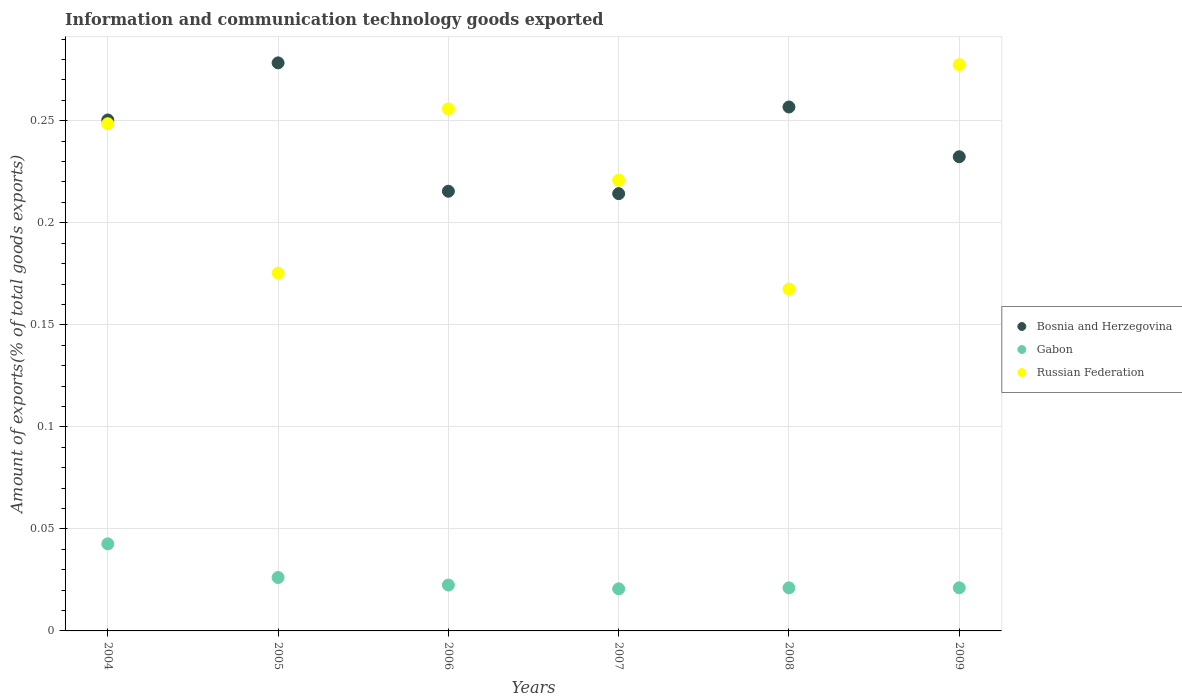Is the number of dotlines equal to the number of legend labels?
Make the answer very short. Yes. What is the amount of goods exported in Gabon in 2009?
Offer a terse response. 0.02. Across all years, what is the maximum amount of goods exported in Gabon?
Your response must be concise. 0.04. Across all years, what is the minimum amount of goods exported in Gabon?
Provide a succinct answer. 0.02. What is the total amount of goods exported in Bosnia and Herzegovina in the graph?
Your response must be concise. 1.45. What is the difference between the amount of goods exported in Gabon in 2004 and that in 2006?
Offer a very short reply. 0.02. What is the difference between the amount of goods exported in Bosnia and Herzegovina in 2005 and the amount of goods exported in Russian Federation in 2007?
Ensure brevity in your answer.  0.06. What is the average amount of goods exported in Russian Federation per year?
Ensure brevity in your answer.  0.22. In the year 2007, what is the difference between the amount of goods exported in Gabon and amount of goods exported in Russian Federation?
Provide a succinct answer. -0.2. What is the ratio of the amount of goods exported in Gabon in 2004 to that in 2009?
Keep it short and to the point. 2.02. Is the difference between the amount of goods exported in Gabon in 2005 and 2009 greater than the difference between the amount of goods exported in Russian Federation in 2005 and 2009?
Your answer should be very brief. Yes. What is the difference between the highest and the second highest amount of goods exported in Russian Federation?
Provide a short and direct response. 0.02. What is the difference between the highest and the lowest amount of goods exported in Gabon?
Your answer should be very brief. 0.02. Is the sum of the amount of goods exported in Russian Federation in 2007 and 2009 greater than the maximum amount of goods exported in Gabon across all years?
Provide a short and direct response. Yes. Is it the case that in every year, the sum of the amount of goods exported in Russian Federation and amount of goods exported in Bosnia and Herzegovina  is greater than the amount of goods exported in Gabon?
Offer a very short reply. Yes. Does the amount of goods exported in Russian Federation monotonically increase over the years?
Your response must be concise. No. Is the amount of goods exported in Russian Federation strictly greater than the amount of goods exported in Gabon over the years?
Ensure brevity in your answer.  Yes. Is the amount of goods exported in Bosnia and Herzegovina strictly less than the amount of goods exported in Gabon over the years?
Ensure brevity in your answer.  No. How many years are there in the graph?
Your answer should be compact. 6. What is the difference between two consecutive major ticks on the Y-axis?
Offer a terse response. 0.05. Are the values on the major ticks of Y-axis written in scientific E-notation?
Give a very brief answer. No. Does the graph contain any zero values?
Offer a terse response. No. Does the graph contain grids?
Offer a very short reply. Yes. Where does the legend appear in the graph?
Your answer should be compact. Center right. How are the legend labels stacked?
Make the answer very short. Vertical. What is the title of the graph?
Give a very brief answer. Information and communication technology goods exported. What is the label or title of the X-axis?
Offer a very short reply. Years. What is the label or title of the Y-axis?
Ensure brevity in your answer.  Amount of exports(% of total goods exports). What is the Amount of exports(% of total goods exports) in Bosnia and Herzegovina in 2004?
Provide a short and direct response. 0.25. What is the Amount of exports(% of total goods exports) in Gabon in 2004?
Give a very brief answer. 0.04. What is the Amount of exports(% of total goods exports) in Russian Federation in 2004?
Your answer should be compact. 0.25. What is the Amount of exports(% of total goods exports) in Bosnia and Herzegovina in 2005?
Your answer should be very brief. 0.28. What is the Amount of exports(% of total goods exports) in Gabon in 2005?
Offer a very short reply. 0.03. What is the Amount of exports(% of total goods exports) in Russian Federation in 2005?
Your answer should be compact. 0.18. What is the Amount of exports(% of total goods exports) in Bosnia and Herzegovina in 2006?
Your answer should be very brief. 0.22. What is the Amount of exports(% of total goods exports) of Gabon in 2006?
Your response must be concise. 0.02. What is the Amount of exports(% of total goods exports) in Russian Federation in 2006?
Offer a very short reply. 0.26. What is the Amount of exports(% of total goods exports) in Bosnia and Herzegovina in 2007?
Your response must be concise. 0.21. What is the Amount of exports(% of total goods exports) of Gabon in 2007?
Provide a succinct answer. 0.02. What is the Amount of exports(% of total goods exports) of Russian Federation in 2007?
Provide a succinct answer. 0.22. What is the Amount of exports(% of total goods exports) in Bosnia and Herzegovina in 2008?
Your answer should be very brief. 0.26. What is the Amount of exports(% of total goods exports) in Gabon in 2008?
Your response must be concise. 0.02. What is the Amount of exports(% of total goods exports) of Russian Federation in 2008?
Your response must be concise. 0.17. What is the Amount of exports(% of total goods exports) in Bosnia and Herzegovina in 2009?
Give a very brief answer. 0.23. What is the Amount of exports(% of total goods exports) in Gabon in 2009?
Offer a terse response. 0.02. What is the Amount of exports(% of total goods exports) in Russian Federation in 2009?
Offer a very short reply. 0.28. Across all years, what is the maximum Amount of exports(% of total goods exports) in Bosnia and Herzegovina?
Your response must be concise. 0.28. Across all years, what is the maximum Amount of exports(% of total goods exports) in Gabon?
Offer a very short reply. 0.04. Across all years, what is the maximum Amount of exports(% of total goods exports) of Russian Federation?
Your answer should be very brief. 0.28. Across all years, what is the minimum Amount of exports(% of total goods exports) of Bosnia and Herzegovina?
Your answer should be compact. 0.21. Across all years, what is the minimum Amount of exports(% of total goods exports) in Gabon?
Ensure brevity in your answer.  0.02. Across all years, what is the minimum Amount of exports(% of total goods exports) in Russian Federation?
Give a very brief answer. 0.17. What is the total Amount of exports(% of total goods exports) in Bosnia and Herzegovina in the graph?
Offer a terse response. 1.45. What is the total Amount of exports(% of total goods exports) in Gabon in the graph?
Provide a succinct answer. 0.15. What is the total Amount of exports(% of total goods exports) in Russian Federation in the graph?
Give a very brief answer. 1.35. What is the difference between the Amount of exports(% of total goods exports) in Bosnia and Herzegovina in 2004 and that in 2005?
Offer a terse response. -0.03. What is the difference between the Amount of exports(% of total goods exports) of Gabon in 2004 and that in 2005?
Make the answer very short. 0.02. What is the difference between the Amount of exports(% of total goods exports) of Russian Federation in 2004 and that in 2005?
Provide a short and direct response. 0.07. What is the difference between the Amount of exports(% of total goods exports) in Bosnia and Herzegovina in 2004 and that in 2006?
Your answer should be compact. 0.03. What is the difference between the Amount of exports(% of total goods exports) of Gabon in 2004 and that in 2006?
Ensure brevity in your answer.  0.02. What is the difference between the Amount of exports(% of total goods exports) of Russian Federation in 2004 and that in 2006?
Provide a succinct answer. -0.01. What is the difference between the Amount of exports(% of total goods exports) of Bosnia and Herzegovina in 2004 and that in 2007?
Offer a very short reply. 0.04. What is the difference between the Amount of exports(% of total goods exports) of Gabon in 2004 and that in 2007?
Keep it short and to the point. 0.02. What is the difference between the Amount of exports(% of total goods exports) of Russian Federation in 2004 and that in 2007?
Keep it short and to the point. 0.03. What is the difference between the Amount of exports(% of total goods exports) of Bosnia and Herzegovina in 2004 and that in 2008?
Give a very brief answer. -0.01. What is the difference between the Amount of exports(% of total goods exports) in Gabon in 2004 and that in 2008?
Offer a very short reply. 0.02. What is the difference between the Amount of exports(% of total goods exports) of Russian Federation in 2004 and that in 2008?
Offer a terse response. 0.08. What is the difference between the Amount of exports(% of total goods exports) of Bosnia and Herzegovina in 2004 and that in 2009?
Your answer should be very brief. 0.02. What is the difference between the Amount of exports(% of total goods exports) in Gabon in 2004 and that in 2009?
Offer a very short reply. 0.02. What is the difference between the Amount of exports(% of total goods exports) of Russian Federation in 2004 and that in 2009?
Your answer should be compact. -0.03. What is the difference between the Amount of exports(% of total goods exports) of Bosnia and Herzegovina in 2005 and that in 2006?
Your response must be concise. 0.06. What is the difference between the Amount of exports(% of total goods exports) in Gabon in 2005 and that in 2006?
Ensure brevity in your answer.  0. What is the difference between the Amount of exports(% of total goods exports) of Russian Federation in 2005 and that in 2006?
Give a very brief answer. -0.08. What is the difference between the Amount of exports(% of total goods exports) in Bosnia and Herzegovina in 2005 and that in 2007?
Keep it short and to the point. 0.06. What is the difference between the Amount of exports(% of total goods exports) of Gabon in 2005 and that in 2007?
Ensure brevity in your answer.  0.01. What is the difference between the Amount of exports(% of total goods exports) of Russian Federation in 2005 and that in 2007?
Ensure brevity in your answer.  -0.05. What is the difference between the Amount of exports(% of total goods exports) in Bosnia and Herzegovina in 2005 and that in 2008?
Give a very brief answer. 0.02. What is the difference between the Amount of exports(% of total goods exports) in Gabon in 2005 and that in 2008?
Ensure brevity in your answer.  0.01. What is the difference between the Amount of exports(% of total goods exports) of Russian Federation in 2005 and that in 2008?
Your answer should be very brief. 0.01. What is the difference between the Amount of exports(% of total goods exports) of Bosnia and Herzegovina in 2005 and that in 2009?
Offer a very short reply. 0.05. What is the difference between the Amount of exports(% of total goods exports) in Gabon in 2005 and that in 2009?
Your answer should be compact. 0.01. What is the difference between the Amount of exports(% of total goods exports) in Russian Federation in 2005 and that in 2009?
Keep it short and to the point. -0.1. What is the difference between the Amount of exports(% of total goods exports) in Bosnia and Herzegovina in 2006 and that in 2007?
Ensure brevity in your answer.  0. What is the difference between the Amount of exports(% of total goods exports) in Gabon in 2006 and that in 2007?
Offer a very short reply. 0. What is the difference between the Amount of exports(% of total goods exports) in Russian Federation in 2006 and that in 2007?
Provide a short and direct response. 0.03. What is the difference between the Amount of exports(% of total goods exports) in Bosnia and Herzegovina in 2006 and that in 2008?
Ensure brevity in your answer.  -0.04. What is the difference between the Amount of exports(% of total goods exports) in Gabon in 2006 and that in 2008?
Offer a terse response. 0. What is the difference between the Amount of exports(% of total goods exports) in Russian Federation in 2006 and that in 2008?
Offer a very short reply. 0.09. What is the difference between the Amount of exports(% of total goods exports) of Bosnia and Herzegovina in 2006 and that in 2009?
Make the answer very short. -0.02. What is the difference between the Amount of exports(% of total goods exports) in Gabon in 2006 and that in 2009?
Give a very brief answer. 0. What is the difference between the Amount of exports(% of total goods exports) in Russian Federation in 2006 and that in 2009?
Provide a short and direct response. -0.02. What is the difference between the Amount of exports(% of total goods exports) in Bosnia and Herzegovina in 2007 and that in 2008?
Provide a succinct answer. -0.04. What is the difference between the Amount of exports(% of total goods exports) in Gabon in 2007 and that in 2008?
Your answer should be compact. -0. What is the difference between the Amount of exports(% of total goods exports) in Russian Federation in 2007 and that in 2008?
Make the answer very short. 0.05. What is the difference between the Amount of exports(% of total goods exports) in Bosnia and Herzegovina in 2007 and that in 2009?
Ensure brevity in your answer.  -0.02. What is the difference between the Amount of exports(% of total goods exports) of Gabon in 2007 and that in 2009?
Provide a short and direct response. -0. What is the difference between the Amount of exports(% of total goods exports) in Russian Federation in 2007 and that in 2009?
Keep it short and to the point. -0.06. What is the difference between the Amount of exports(% of total goods exports) in Bosnia and Herzegovina in 2008 and that in 2009?
Provide a succinct answer. 0.02. What is the difference between the Amount of exports(% of total goods exports) in Russian Federation in 2008 and that in 2009?
Ensure brevity in your answer.  -0.11. What is the difference between the Amount of exports(% of total goods exports) in Bosnia and Herzegovina in 2004 and the Amount of exports(% of total goods exports) in Gabon in 2005?
Offer a very short reply. 0.22. What is the difference between the Amount of exports(% of total goods exports) in Bosnia and Herzegovina in 2004 and the Amount of exports(% of total goods exports) in Russian Federation in 2005?
Ensure brevity in your answer.  0.08. What is the difference between the Amount of exports(% of total goods exports) in Gabon in 2004 and the Amount of exports(% of total goods exports) in Russian Federation in 2005?
Keep it short and to the point. -0.13. What is the difference between the Amount of exports(% of total goods exports) of Bosnia and Herzegovina in 2004 and the Amount of exports(% of total goods exports) of Gabon in 2006?
Your answer should be very brief. 0.23. What is the difference between the Amount of exports(% of total goods exports) of Bosnia and Herzegovina in 2004 and the Amount of exports(% of total goods exports) of Russian Federation in 2006?
Give a very brief answer. -0.01. What is the difference between the Amount of exports(% of total goods exports) in Gabon in 2004 and the Amount of exports(% of total goods exports) in Russian Federation in 2006?
Your response must be concise. -0.21. What is the difference between the Amount of exports(% of total goods exports) of Bosnia and Herzegovina in 2004 and the Amount of exports(% of total goods exports) of Gabon in 2007?
Provide a short and direct response. 0.23. What is the difference between the Amount of exports(% of total goods exports) in Bosnia and Herzegovina in 2004 and the Amount of exports(% of total goods exports) in Russian Federation in 2007?
Your response must be concise. 0.03. What is the difference between the Amount of exports(% of total goods exports) in Gabon in 2004 and the Amount of exports(% of total goods exports) in Russian Federation in 2007?
Your answer should be very brief. -0.18. What is the difference between the Amount of exports(% of total goods exports) of Bosnia and Herzegovina in 2004 and the Amount of exports(% of total goods exports) of Gabon in 2008?
Your response must be concise. 0.23. What is the difference between the Amount of exports(% of total goods exports) of Bosnia and Herzegovina in 2004 and the Amount of exports(% of total goods exports) of Russian Federation in 2008?
Offer a terse response. 0.08. What is the difference between the Amount of exports(% of total goods exports) of Gabon in 2004 and the Amount of exports(% of total goods exports) of Russian Federation in 2008?
Ensure brevity in your answer.  -0.12. What is the difference between the Amount of exports(% of total goods exports) in Bosnia and Herzegovina in 2004 and the Amount of exports(% of total goods exports) in Gabon in 2009?
Your answer should be compact. 0.23. What is the difference between the Amount of exports(% of total goods exports) in Bosnia and Herzegovina in 2004 and the Amount of exports(% of total goods exports) in Russian Federation in 2009?
Provide a succinct answer. -0.03. What is the difference between the Amount of exports(% of total goods exports) in Gabon in 2004 and the Amount of exports(% of total goods exports) in Russian Federation in 2009?
Make the answer very short. -0.23. What is the difference between the Amount of exports(% of total goods exports) in Bosnia and Herzegovina in 2005 and the Amount of exports(% of total goods exports) in Gabon in 2006?
Provide a short and direct response. 0.26. What is the difference between the Amount of exports(% of total goods exports) of Bosnia and Herzegovina in 2005 and the Amount of exports(% of total goods exports) of Russian Federation in 2006?
Provide a short and direct response. 0.02. What is the difference between the Amount of exports(% of total goods exports) in Gabon in 2005 and the Amount of exports(% of total goods exports) in Russian Federation in 2006?
Provide a short and direct response. -0.23. What is the difference between the Amount of exports(% of total goods exports) of Bosnia and Herzegovina in 2005 and the Amount of exports(% of total goods exports) of Gabon in 2007?
Offer a very short reply. 0.26. What is the difference between the Amount of exports(% of total goods exports) in Bosnia and Herzegovina in 2005 and the Amount of exports(% of total goods exports) in Russian Federation in 2007?
Offer a terse response. 0.06. What is the difference between the Amount of exports(% of total goods exports) of Gabon in 2005 and the Amount of exports(% of total goods exports) of Russian Federation in 2007?
Give a very brief answer. -0.19. What is the difference between the Amount of exports(% of total goods exports) in Bosnia and Herzegovina in 2005 and the Amount of exports(% of total goods exports) in Gabon in 2008?
Make the answer very short. 0.26. What is the difference between the Amount of exports(% of total goods exports) of Bosnia and Herzegovina in 2005 and the Amount of exports(% of total goods exports) of Russian Federation in 2008?
Your response must be concise. 0.11. What is the difference between the Amount of exports(% of total goods exports) of Gabon in 2005 and the Amount of exports(% of total goods exports) of Russian Federation in 2008?
Make the answer very short. -0.14. What is the difference between the Amount of exports(% of total goods exports) of Bosnia and Herzegovina in 2005 and the Amount of exports(% of total goods exports) of Gabon in 2009?
Make the answer very short. 0.26. What is the difference between the Amount of exports(% of total goods exports) of Bosnia and Herzegovina in 2005 and the Amount of exports(% of total goods exports) of Russian Federation in 2009?
Your answer should be very brief. 0. What is the difference between the Amount of exports(% of total goods exports) in Gabon in 2005 and the Amount of exports(% of total goods exports) in Russian Federation in 2009?
Keep it short and to the point. -0.25. What is the difference between the Amount of exports(% of total goods exports) in Bosnia and Herzegovina in 2006 and the Amount of exports(% of total goods exports) in Gabon in 2007?
Your response must be concise. 0.19. What is the difference between the Amount of exports(% of total goods exports) of Bosnia and Herzegovina in 2006 and the Amount of exports(% of total goods exports) of Russian Federation in 2007?
Your answer should be very brief. -0.01. What is the difference between the Amount of exports(% of total goods exports) in Gabon in 2006 and the Amount of exports(% of total goods exports) in Russian Federation in 2007?
Make the answer very short. -0.2. What is the difference between the Amount of exports(% of total goods exports) in Bosnia and Herzegovina in 2006 and the Amount of exports(% of total goods exports) in Gabon in 2008?
Offer a terse response. 0.19. What is the difference between the Amount of exports(% of total goods exports) in Bosnia and Herzegovina in 2006 and the Amount of exports(% of total goods exports) in Russian Federation in 2008?
Offer a very short reply. 0.05. What is the difference between the Amount of exports(% of total goods exports) in Gabon in 2006 and the Amount of exports(% of total goods exports) in Russian Federation in 2008?
Provide a short and direct response. -0.14. What is the difference between the Amount of exports(% of total goods exports) in Bosnia and Herzegovina in 2006 and the Amount of exports(% of total goods exports) in Gabon in 2009?
Your response must be concise. 0.19. What is the difference between the Amount of exports(% of total goods exports) of Bosnia and Herzegovina in 2006 and the Amount of exports(% of total goods exports) of Russian Federation in 2009?
Your response must be concise. -0.06. What is the difference between the Amount of exports(% of total goods exports) of Gabon in 2006 and the Amount of exports(% of total goods exports) of Russian Federation in 2009?
Make the answer very short. -0.26. What is the difference between the Amount of exports(% of total goods exports) of Bosnia and Herzegovina in 2007 and the Amount of exports(% of total goods exports) of Gabon in 2008?
Offer a very short reply. 0.19. What is the difference between the Amount of exports(% of total goods exports) in Bosnia and Herzegovina in 2007 and the Amount of exports(% of total goods exports) in Russian Federation in 2008?
Ensure brevity in your answer.  0.05. What is the difference between the Amount of exports(% of total goods exports) of Gabon in 2007 and the Amount of exports(% of total goods exports) of Russian Federation in 2008?
Your answer should be very brief. -0.15. What is the difference between the Amount of exports(% of total goods exports) of Bosnia and Herzegovina in 2007 and the Amount of exports(% of total goods exports) of Gabon in 2009?
Provide a succinct answer. 0.19. What is the difference between the Amount of exports(% of total goods exports) in Bosnia and Herzegovina in 2007 and the Amount of exports(% of total goods exports) in Russian Federation in 2009?
Give a very brief answer. -0.06. What is the difference between the Amount of exports(% of total goods exports) in Gabon in 2007 and the Amount of exports(% of total goods exports) in Russian Federation in 2009?
Your response must be concise. -0.26. What is the difference between the Amount of exports(% of total goods exports) in Bosnia and Herzegovina in 2008 and the Amount of exports(% of total goods exports) in Gabon in 2009?
Your answer should be very brief. 0.24. What is the difference between the Amount of exports(% of total goods exports) in Bosnia and Herzegovina in 2008 and the Amount of exports(% of total goods exports) in Russian Federation in 2009?
Keep it short and to the point. -0.02. What is the difference between the Amount of exports(% of total goods exports) in Gabon in 2008 and the Amount of exports(% of total goods exports) in Russian Federation in 2009?
Keep it short and to the point. -0.26. What is the average Amount of exports(% of total goods exports) of Bosnia and Herzegovina per year?
Make the answer very short. 0.24. What is the average Amount of exports(% of total goods exports) in Gabon per year?
Provide a short and direct response. 0.03. What is the average Amount of exports(% of total goods exports) in Russian Federation per year?
Your answer should be very brief. 0.22. In the year 2004, what is the difference between the Amount of exports(% of total goods exports) of Bosnia and Herzegovina and Amount of exports(% of total goods exports) of Gabon?
Your answer should be very brief. 0.21. In the year 2004, what is the difference between the Amount of exports(% of total goods exports) in Bosnia and Herzegovina and Amount of exports(% of total goods exports) in Russian Federation?
Offer a terse response. 0. In the year 2004, what is the difference between the Amount of exports(% of total goods exports) in Gabon and Amount of exports(% of total goods exports) in Russian Federation?
Ensure brevity in your answer.  -0.21. In the year 2005, what is the difference between the Amount of exports(% of total goods exports) in Bosnia and Herzegovina and Amount of exports(% of total goods exports) in Gabon?
Your answer should be very brief. 0.25. In the year 2005, what is the difference between the Amount of exports(% of total goods exports) in Bosnia and Herzegovina and Amount of exports(% of total goods exports) in Russian Federation?
Ensure brevity in your answer.  0.1. In the year 2005, what is the difference between the Amount of exports(% of total goods exports) of Gabon and Amount of exports(% of total goods exports) of Russian Federation?
Provide a short and direct response. -0.15. In the year 2006, what is the difference between the Amount of exports(% of total goods exports) in Bosnia and Herzegovina and Amount of exports(% of total goods exports) in Gabon?
Provide a succinct answer. 0.19. In the year 2006, what is the difference between the Amount of exports(% of total goods exports) in Bosnia and Herzegovina and Amount of exports(% of total goods exports) in Russian Federation?
Keep it short and to the point. -0.04. In the year 2006, what is the difference between the Amount of exports(% of total goods exports) in Gabon and Amount of exports(% of total goods exports) in Russian Federation?
Ensure brevity in your answer.  -0.23. In the year 2007, what is the difference between the Amount of exports(% of total goods exports) of Bosnia and Herzegovina and Amount of exports(% of total goods exports) of Gabon?
Your answer should be very brief. 0.19. In the year 2007, what is the difference between the Amount of exports(% of total goods exports) of Bosnia and Herzegovina and Amount of exports(% of total goods exports) of Russian Federation?
Keep it short and to the point. -0.01. In the year 2007, what is the difference between the Amount of exports(% of total goods exports) of Gabon and Amount of exports(% of total goods exports) of Russian Federation?
Offer a terse response. -0.2. In the year 2008, what is the difference between the Amount of exports(% of total goods exports) in Bosnia and Herzegovina and Amount of exports(% of total goods exports) in Gabon?
Make the answer very short. 0.24. In the year 2008, what is the difference between the Amount of exports(% of total goods exports) of Bosnia and Herzegovina and Amount of exports(% of total goods exports) of Russian Federation?
Give a very brief answer. 0.09. In the year 2008, what is the difference between the Amount of exports(% of total goods exports) in Gabon and Amount of exports(% of total goods exports) in Russian Federation?
Your answer should be compact. -0.15. In the year 2009, what is the difference between the Amount of exports(% of total goods exports) in Bosnia and Herzegovina and Amount of exports(% of total goods exports) in Gabon?
Give a very brief answer. 0.21. In the year 2009, what is the difference between the Amount of exports(% of total goods exports) in Bosnia and Herzegovina and Amount of exports(% of total goods exports) in Russian Federation?
Your answer should be compact. -0.05. In the year 2009, what is the difference between the Amount of exports(% of total goods exports) of Gabon and Amount of exports(% of total goods exports) of Russian Federation?
Provide a short and direct response. -0.26. What is the ratio of the Amount of exports(% of total goods exports) of Bosnia and Herzegovina in 2004 to that in 2005?
Your answer should be very brief. 0.9. What is the ratio of the Amount of exports(% of total goods exports) in Gabon in 2004 to that in 2005?
Offer a terse response. 1.63. What is the ratio of the Amount of exports(% of total goods exports) of Russian Federation in 2004 to that in 2005?
Provide a short and direct response. 1.42. What is the ratio of the Amount of exports(% of total goods exports) in Bosnia and Herzegovina in 2004 to that in 2006?
Ensure brevity in your answer.  1.16. What is the ratio of the Amount of exports(% of total goods exports) of Gabon in 2004 to that in 2006?
Make the answer very short. 1.9. What is the ratio of the Amount of exports(% of total goods exports) of Russian Federation in 2004 to that in 2006?
Offer a very short reply. 0.97. What is the ratio of the Amount of exports(% of total goods exports) in Bosnia and Herzegovina in 2004 to that in 2007?
Offer a terse response. 1.17. What is the ratio of the Amount of exports(% of total goods exports) of Gabon in 2004 to that in 2007?
Your answer should be compact. 2.07. What is the ratio of the Amount of exports(% of total goods exports) in Russian Federation in 2004 to that in 2007?
Make the answer very short. 1.13. What is the ratio of the Amount of exports(% of total goods exports) in Bosnia and Herzegovina in 2004 to that in 2008?
Ensure brevity in your answer.  0.98. What is the ratio of the Amount of exports(% of total goods exports) of Gabon in 2004 to that in 2008?
Offer a terse response. 2.02. What is the ratio of the Amount of exports(% of total goods exports) of Russian Federation in 2004 to that in 2008?
Provide a succinct answer. 1.48. What is the ratio of the Amount of exports(% of total goods exports) in Bosnia and Herzegovina in 2004 to that in 2009?
Provide a succinct answer. 1.08. What is the ratio of the Amount of exports(% of total goods exports) in Gabon in 2004 to that in 2009?
Give a very brief answer. 2.02. What is the ratio of the Amount of exports(% of total goods exports) in Russian Federation in 2004 to that in 2009?
Offer a terse response. 0.9. What is the ratio of the Amount of exports(% of total goods exports) in Bosnia and Herzegovina in 2005 to that in 2006?
Provide a short and direct response. 1.29. What is the ratio of the Amount of exports(% of total goods exports) of Gabon in 2005 to that in 2006?
Keep it short and to the point. 1.16. What is the ratio of the Amount of exports(% of total goods exports) of Russian Federation in 2005 to that in 2006?
Provide a succinct answer. 0.69. What is the ratio of the Amount of exports(% of total goods exports) in Bosnia and Herzegovina in 2005 to that in 2007?
Offer a very short reply. 1.3. What is the ratio of the Amount of exports(% of total goods exports) in Gabon in 2005 to that in 2007?
Provide a short and direct response. 1.27. What is the ratio of the Amount of exports(% of total goods exports) in Russian Federation in 2005 to that in 2007?
Make the answer very short. 0.79. What is the ratio of the Amount of exports(% of total goods exports) of Bosnia and Herzegovina in 2005 to that in 2008?
Give a very brief answer. 1.08. What is the ratio of the Amount of exports(% of total goods exports) of Gabon in 2005 to that in 2008?
Your answer should be compact. 1.24. What is the ratio of the Amount of exports(% of total goods exports) in Russian Federation in 2005 to that in 2008?
Your answer should be compact. 1.05. What is the ratio of the Amount of exports(% of total goods exports) in Bosnia and Herzegovina in 2005 to that in 2009?
Keep it short and to the point. 1.2. What is the ratio of the Amount of exports(% of total goods exports) in Gabon in 2005 to that in 2009?
Give a very brief answer. 1.24. What is the ratio of the Amount of exports(% of total goods exports) of Russian Federation in 2005 to that in 2009?
Your answer should be very brief. 0.63. What is the ratio of the Amount of exports(% of total goods exports) of Gabon in 2006 to that in 2007?
Make the answer very short. 1.09. What is the ratio of the Amount of exports(% of total goods exports) in Russian Federation in 2006 to that in 2007?
Make the answer very short. 1.16. What is the ratio of the Amount of exports(% of total goods exports) of Bosnia and Herzegovina in 2006 to that in 2008?
Ensure brevity in your answer.  0.84. What is the ratio of the Amount of exports(% of total goods exports) of Gabon in 2006 to that in 2008?
Give a very brief answer. 1.06. What is the ratio of the Amount of exports(% of total goods exports) in Russian Federation in 2006 to that in 2008?
Offer a terse response. 1.53. What is the ratio of the Amount of exports(% of total goods exports) in Bosnia and Herzegovina in 2006 to that in 2009?
Your response must be concise. 0.93. What is the ratio of the Amount of exports(% of total goods exports) of Gabon in 2006 to that in 2009?
Your answer should be compact. 1.06. What is the ratio of the Amount of exports(% of total goods exports) in Russian Federation in 2006 to that in 2009?
Offer a very short reply. 0.92. What is the ratio of the Amount of exports(% of total goods exports) in Bosnia and Herzegovina in 2007 to that in 2008?
Ensure brevity in your answer.  0.83. What is the ratio of the Amount of exports(% of total goods exports) of Gabon in 2007 to that in 2008?
Keep it short and to the point. 0.98. What is the ratio of the Amount of exports(% of total goods exports) in Russian Federation in 2007 to that in 2008?
Ensure brevity in your answer.  1.32. What is the ratio of the Amount of exports(% of total goods exports) of Bosnia and Herzegovina in 2007 to that in 2009?
Your response must be concise. 0.92. What is the ratio of the Amount of exports(% of total goods exports) in Gabon in 2007 to that in 2009?
Ensure brevity in your answer.  0.98. What is the ratio of the Amount of exports(% of total goods exports) in Russian Federation in 2007 to that in 2009?
Provide a succinct answer. 0.8. What is the ratio of the Amount of exports(% of total goods exports) of Bosnia and Herzegovina in 2008 to that in 2009?
Provide a succinct answer. 1.1. What is the ratio of the Amount of exports(% of total goods exports) of Gabon in 2008 to that in 2009?
Ensure brevity in your answer.  1. What is the ratio of the Amount of exports(% of total goods exports) in Russian Federation in 2008 to that in 2009?
Provide a short and direct response. 0.6. What is the difference between the highest and the second highest Amount of exports(% of total goods exports) of Bosnia and Herzegovina?
Your response must be concise. 0.02. What is the difference between the highest and the second highest Amount of exports(% of total goods exports) in Gabon?
Ensure brevity in your answer.  0.02. What is the difference between the highest and the second highest Amount of exports(% of total goods exports) of Russian Federation?
Your answer should be very brief. 0.02. What is the difference between the highest and the lowest Amount of exports(% of total goods exports) of Bosnia and Herzegovina?
Your response must be concise. 0.06. What is the difference between the highest and the lowest Amount of exports(% of total goods exports) of Gabon?
Provide a succinct answer. 0.02. What is the difference between the highest and the lowest Amount of exports(% of total goods exports) of Russian Federation?
Ensure brevity in your answer.  0.11. 